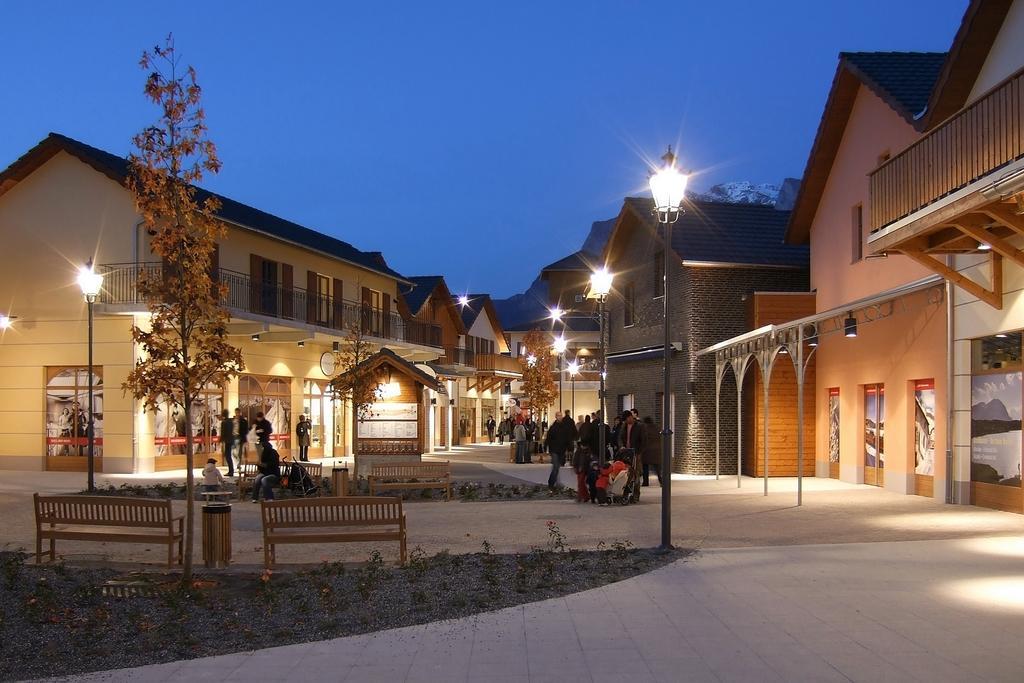Please provide a concise description of this image. In the picture we can see a street with a house and to it we can see windows and railings and in the middle of the houses we can see a path and near the path we can see some poles with lights and some people are standing near to it and in the middle of the path we can see some grass path and on it we can see small hut and a light to it and near to it we can see another path with grass and two benches on it with a tree beside it and in the background we can see a sky. 